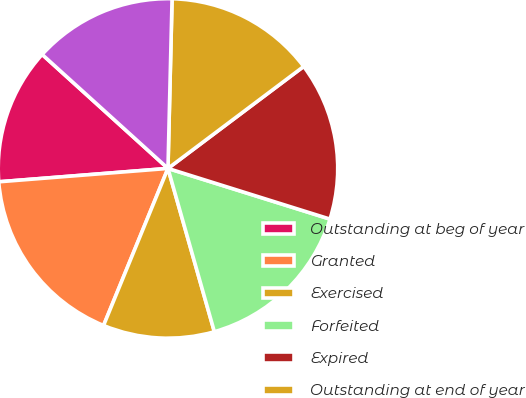Convert chart. <chart><loc_0><loc_0><loc_500><loc_500><pie_chart><fcel>Outstanding at beg of year<fcel>Granted<fcel>Exercised<fcel>Forfeited<fcel>Expired<fcel>Outstanding at end of year<fcel>Exercisable at end of year<nl><fcel>12.97%<fcel>17.55%<fcel>10.6%<fcel>15.77%<fcel>15.08%<fcel>14.36%<fcel>13.67%<nl></chart> 